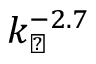Convert formula to latex. <formula><loc_0><loc_0><loc_500><loc_500>k _ { \perp } ^ { - 2 . 7 }</formula> 